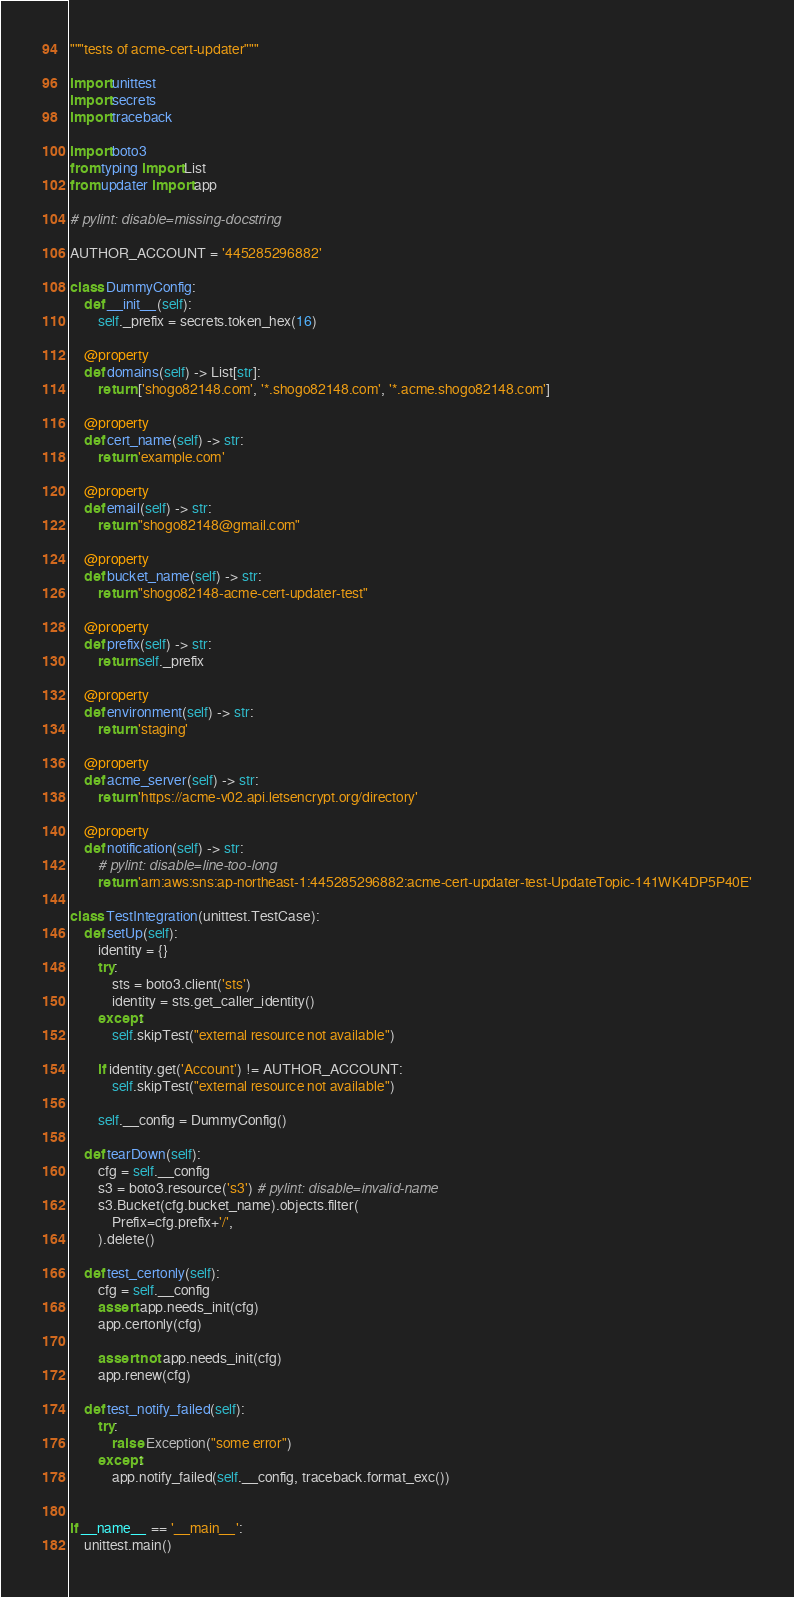Convert code to text. <code><loc_0><loc_0><loc_500><loc_500><_Python_>"""tests of acme-cert-updater"""

import unittest
import secrets
import traceback

import boto3
from typing import List
from updater import app

# pylint: disable=missing-docstring

AUTHOR_ACCOUNT = '445285296882'

class DummyConfig:
    def __init__(self):
        self._prefix = secrets.token_hex(16)

    @property
    def domains(self) -> List[str]:
        return ['shogo82148.com', '*.shogo82148.com', '*.acme.shogo82148.com']

    @property
    def cert_name(self) -> str:
        return 'example.com'

    @property
    def email(self) -> str:
        return "shogo82148@gmail.com"

    @property
    def bucket_name(self) -> str:
        return "shogo82148-acme-cert-updater-test"

    @property
    def prefix(self) -> str:
        return self._prefix

    @property
    def environment(self) -> str:
        return 'staging'

    @property
    def acme_server(self) -> str:
        return 'https://acme-v02.api.letsencrypt.org/directory'

    @property
    def notification(self) -> str:
        # pylint: disable=line-too-long
        return 'arn:aws:sns:ap-northeast-1:445285296882:acme-cert-updater-test-UpdateTopic-141WK4DP5P40E'

class TestIntegration(unittest.TestCase):
    def setUp(self):
        identity = {}
        try:
            sts = boto3.client('sts')
            identity = sts.get_caller_identity()
        except:
            self.skipTest("external resource not available")

        if identity.get('Account') != AUTHOR_ACCOUNT:
            self.skipTest("external resource not available")

        self.__config = DummyConfig()
    
    def tearDown(self):
        cfg = self.__config
        s3 = boto3.resource('s3') # pylint: disable=invalid-name
        s3.Bucket(cfg.bucket_name).objects.filter(
            Prefix=cfg.prefix+'/',
        ).delete()

    def test_certonly(self):
        cfg = self.__config
        assert app.needs_init(cfg)
        app.certonly(cfg)

        assert not app.needs_init(cfg)
        app.renew(cfg)

    def test_notify_failed(self):
        try:
            raise Exception("some error")
        except:
            app.notify_failed(self.__config, traceback.format_exc())


if __name__ == '__main__':
    unittest.main()
</code> 